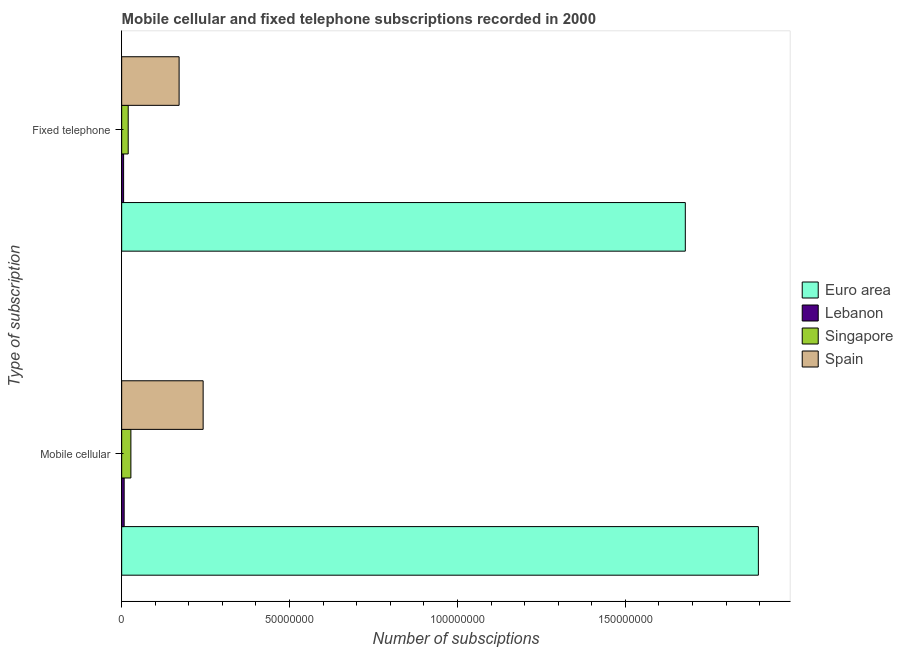How many different coloured bars are there?
Provide a succinct answer. 4. How many groups of bars are there?
Your answer should be very brief. 2. What is the label of the 1st group of bars from the top?
Your response must be concise. Fixed telephone. What is the number of mobile cellular subscriptions in Lebanon?
Give a very brief answer. 7.43e+05. Across all countries, what is the maximum number of fixed telephone subscriptions?
Provide a succinct answer. 1.68e+08. Across all countries, what is the minimum number of fixed telephone subscriptions?
Your answer should be compact. 5.76e+05. In which country was the number of fixed telephone subscriptions maximum?
Make the answer very short. Euro area. In which country was the number of fixed telephone subscriptions minimum?
Offer a terse response. Lebanon. What is the total number of mobile cellular subscriptions in the graph?
Give a very brief answer. 2.17e+08. What is the difference between the number of mobile cellular subscriptions in Singapore and that in Euro area?
Provide a short and direct response. -1.87e+08. What is the difference between the number of mobile cellular subscriptions in Lebanon and the number of fixed telephone subscriptions in Spain?
Give a very brief answer. -1.64e+07. What is the average number of fixed telephone subscriptions per country?
Ensure brevity in your answer.  4.69e+07. What is the difference between the number of mobile cellular subscriptions and number of fixed telephone subscriptions in Singapore?
Your answer should be compact. 8.01e+05. What is the ratio of the number of mobile cellular subscriptions in Lebanon to that in Spain?
Give a very brief answer. 0.03. In how many countries, is the number of mobile cellular subscriptions greater than the average number of mobile cellular subscriptions taken over all countries?
Provide a succinct answer. 1. What does the 3rd bar from the top in Fixed telephone represents?
Make the answer very short. Lebanon. How many countries are there in the graph?
Provide a short and direct response. 4. How are the legend labels stacked?
Your answer should be compact. Vertical. What is the title of the graph?
Give a very brief answer. Mobile cellular and fixed telephone subscriptions recorded in 2000. What is the label or title of the X-axis?
Provide a short and direct response. Number of subsciptions. What is the label or title of the Y-axis?
Make the answer very short. Type of subscription. What is the Number of subsciptions in Euro area in Mobile cellular?
Ensure brevity in your answer.  1.90e+08. What is the Number of subsciptions of Lebanon in Mobile cellular?
Keep it short and to the point. 7.43e+05. What is the Number of subsciptions of Singapore in Mobile cellular?
Ensure brevity in your answer.  2.75e+06. What is the Number of subsciptions of Spain in Mobile cellular?
Ensure brevity in your answer.  2.43e+07. What is the Number of subsciptions of Euro area in Fixed telephone?
Give a very brief answer. 1.68e+08. What is the Number of subsciptions of Lebanon in Fixed telephone?
Provide a short and direct response. 5.76e+05. What is the Number of subsciptions in Singapore in Fixed telephone?
Provide a succinct answer. 1.95e+06. What is the Number of subsciptions of Spain in Fixed telephone?
Provide a succinct answer. 1.71e+07. Across all Type of subscription, what is the maximum Number of subsciptions in Euro area?
Give a very brief answer. 1.90e+08. Across all Type of subscription, what is the maximum Number of subsciptions of Lebanon?
Your answer should be compact. 7.43e+05. Across all Type of subscription, what is the maximum Number of subsciptions of Singapore?
Keep it short and to the point. 2.75e+06. Across all Type of subscription, what is the maximum Number of subsciptions of Spain?
Give a very brief answer. 2.43e+07. Across all Type of subscription, what is the minimum Number of subsciptions of Euro area?
Provide a short and direct response. 1.68e+08. Across all Type of subscription, what is the minimum Number of subsciptions of Lebanon?
Provide a succinct answer. 5.76e+05. Across all Type of subscription, what is the minimum Number of subsciptions of Singapore?
Give a very brief answer. 1.95e+06. Across all Type of subscription, what is the minimum Number of subsciptions of Spain?
Provide a short and direct response. 1.71e+07. What is the total Number of subsciptions of Euro area in the graph?
Offer a very short reply. 3.58e+08. What is the total Number of subsciptions in Lebanon in the graph?
Give a very brief answer. 1.32e+06. What is the total Number of subsciptions in Singapore in the graph?
Give a very brief answer. 4.69e+06. What is the total Number of subsciptions in Spain in the graph?
Keep it short and to the point. 4.14e+07. What is the difference between the Number of subsciptions in Euro area in Mobile cellular and that in Fixed telephone?
Provide a succinct answer. 2.18e+07. What is the difference between the Number of subsciptions of Lebanon in Mobile cellular and that in Fixed telephone?
Your answer should be very brief. 1.67e+05. What is the difference between the Number of subsciptions of Singapore in Mobile cellular and that in Fixed telephone?
Your response must be concise. 8.01e+05. What is the difference between the Number of subsciptions in Spain in Mobile cellular and that in Fixed telephone?
Offer a very short reply. 7.16e+06. What is the difference between the Number of subsciptions in Euro area in Mobile cellular and the Number of subsciptions in Lebanon in Fixed telephone?
Provide a succinct answer. 1.89e+08. What is the difference between the Number of subsciptions of Euro area in Mobile cellular and the Number of subsciptions of Singapore in Fixed telephone?
Offer a very short reply. 1.88e+08. What is the difference between the Number of subsciptions of Euro area in Mobile cellular and the Number of subsciptions of Spain in Fixed telephone?
Keep it short and to the point. 1.73e+08. What is the difference between the Number of subsciptions of Lebanon in Mobile cellular and the Number of subsciptions of Singapore in Fixed telephone?
Give a very brief answer. -1.20e+06. What is the difference between the Number of subsciptions in Lebanon in Mobile cellular and the Number of subsciptions in Spain in Fixed telephone?
Make the answer very short. -1.64e+07. What is the difference between the Number of subsciptions in Singapore in Mobile cellular and the Number of subsciptions in Spain in Fixed telephone?
Your answer should be very brief. -1.44e+07. What is the average Number of subsciptions in Euro area per Type of subscription?
Ensure brevity in your answer.  1.79e+08. What is the average Number of subsciptions in Lebanon per Type of subscription?
Your response must be concise. 6.60e+05. What is the average Number of subsciptions of Singapore per Type of subscription?
Offer a very short reply. 2.35e+06. What is the average Number of subsciptions in Spain per Type of subscription?
Ensure brevity in your answer.  2.07e+07. What is the difference between the Number of subsciptions in Euro area and Number of subsciptions in Lebanon in Mobile cellular?
Keep it short and to the point. 1.89e+08. What is the difference between the Number of subsciptions in Euro area and Number of subsciptions in Singapore in Mobile cellular?
Offer a terse response. 1.87e+08. What is the difference between the Number of subsciptions of Euro area and Number of subsciptions of Spain in Mobile cellular?
Your answer should be very brief. 1.65e+08. What is the difference between the Number of subsciptions in Lebanon and Number of subsciptions in Singapore in Mobile cellular?
Your response must be concise. -2.00e+06. What is the difference between the Number of subsciptions in Lebanon and Number of subsciptions in Spain in Mobile cellular?
Make the answer very short. -2.35e+07. What is the difference between the Number of subsciptions of Singapore and Number of subsciptions of Spain in Mobile cellular?
Give a very brief answer. -2.15e+07. What is the difference between the Number of subsciptions in Euro area and Number of subsciptions in Lebanon in Fixed telephone?
Keep it short and to the point. 1.67e+08. What is the difference between the Number of subsciptions of Euro area and Number of subsciptions of Singapore in Fixed telephone?
Ensure brevity in your answer.  1.66e+08. What is the difference between the Number of subsciptions of Euro area and Number of subsciptions of Spain in Fixed telephone?
Your response must be concise. 1.51e+08. What is the difference between the Number of subsciptions of Lebanon and Number of subsciptions of Singapore in Fixed telephone?
Ensure brevity in your answer.  -1.37e+06. What is the difference between the Number of subsciptions of Lebanon and Number of subsciptions of Spain in Fixed telephone?
Your answer should be very brief. -1.65e+07. What is the difference between the Number of subsciptions in Singapore and Number of subsciptions in Spain in Fixed telephone?
Provide a short and direct response. -1.52e+07. What is the ratio of the Number of subsciptions of Euro area in Mobile cellular to that in Fixed telephone?
Your answer should be very brief. 1.13. What is the ratio of the Number of subsciptions in Lebanon in Mobile cellular to that in Fixed telephone?
Ensure brevity in your answer.  1.29. What is the ratio of the Number of subsciptions in Singapore in Mobile cellular to that in Fixed telephone?
Make the answer very short. 1.41. What is the ratio of the Number of subsciptions of Spain in Mobile cellular to that in Fixed telephone?
Your answer should be very brief. 1.42. What is the difference between the highest and the second highest Number of subsciptions in Euro area?
Provide a short and direct response. 2.18e+07. What is the difference between the highest and the second highest Number of subsciptions in Lebanon?
Provide a short and direct response. 1.67e+05. What is the difference between the highest and the second highest Number of subsciptions of Singapore?
Your answer should be compact. 8.01e+05. What is the difference between the highest and the second highest Number of subsciptions of Spain?
Make the answer very short. 7.16e+06. What is the difference between the highest and the lowest Number of subsciptions in Euro area?
Provide a short and direct response. 2.18e+07. What is the difference between the highest and the lowest Number of subsciptions of Lebanon?
Offer a very short reply. 1.67e+05. What is the difference between the highest and the lowest Number of subsciptions in Singapore?
Make the answer very short. 8.01e+05. What is the difference between the highest and the lowest Number of subsciptions of Spain?
Offer a very short reply. 7.16e+06. 